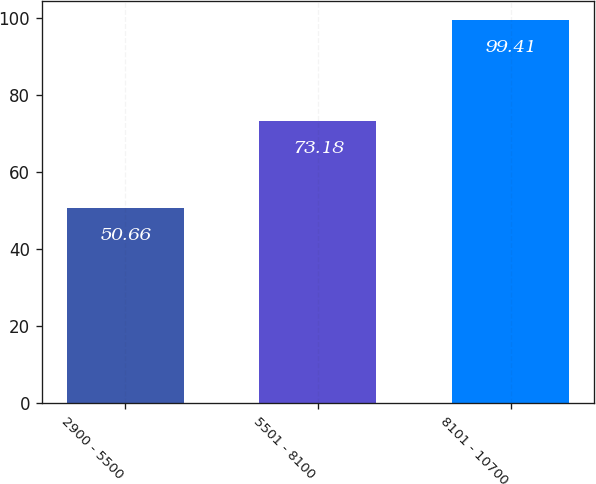Convert chart to OTSL. <chart><loc_0><loc_0><loc_500><loc_500><bar_chart><fcel>2900 - 5500<fcel>5501 - 8100<fcel>8101 - 10700<nl><fcel>50.66<fcel>73.18<fcel>99.41<nl></chart> 